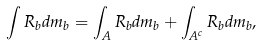<formula> <loc_0><loc_0><loc_500><loc_500>\int R _ { b } d m _ { b } = \int _ { A } R _ { b } d m _ { b } + \int _ { A ^ { c } } R _ { b } d m _ { b } ,</formula> 